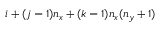<formula> <loc_0><loc_0><loc_500><loc_500>i + ( j - 1 ) n _ { x } + ( k - 1 ) n _ { x } ( n _ { y } + 1 )</formula> 